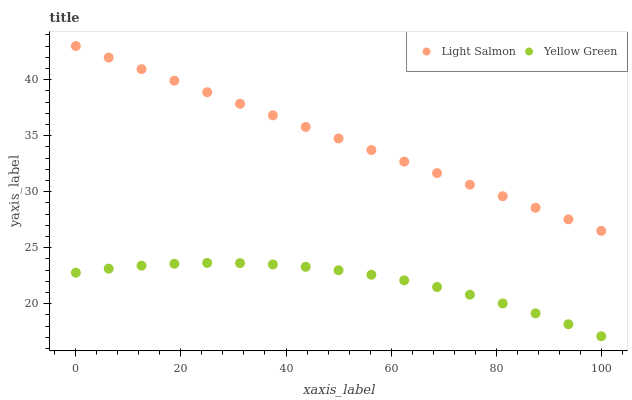Does Yellow Green have the minimum area under the curve?
Answer yes or no. Yes. Does Light Salmon have the maximum area under the curve?
Answer yes or no. Yes. Does Yellow Green have the maximum area under the curve?
Answer yes or no. No. Is Light Salmon the smoothest?
Answer yes or no. Yes. Is Yellow Green the roughest?
Answer yes or no. Yes. Is Yellow Green the smoothest?
Answer yes or no. No. Does Yellow Green have the lowest value?
Answer yes or no. Yes. Does Light Salmon have the highest value?
Answer yes or no. Yes. Does Yellow Green have the highest value?
Answer yes or no. No. Is Yellow Green less than Light Salmon?
Answer yes or no. Yes. Is Light Salmon greater than Yellow Green?
Answer yes or no. Yes. Does Yellow Green intersect Light Salmon?
Answer yes or no. No. 